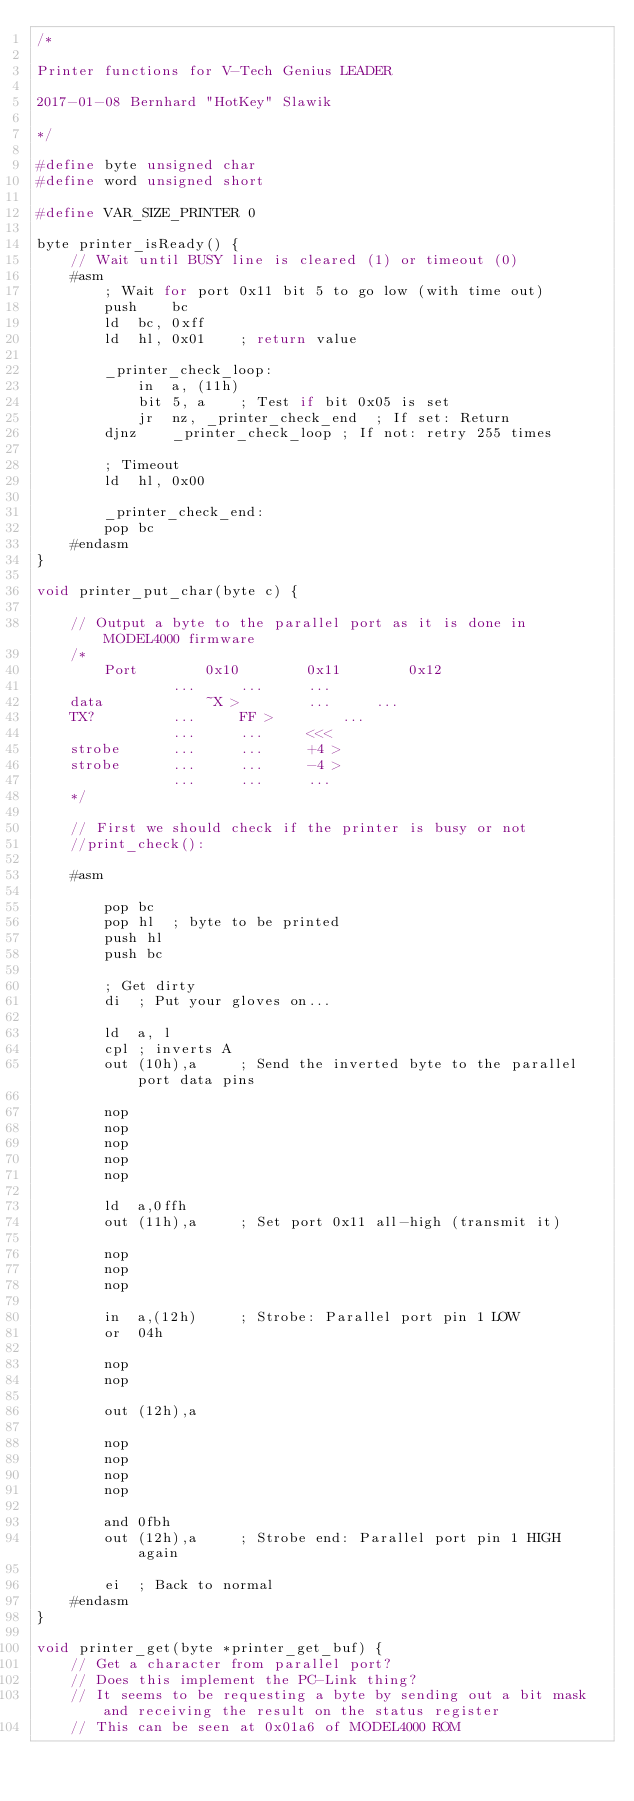<code> <loc_0><loc_0><loc_500><loc_500><_C_>/*

Printer functions for V-Tech Genius LEADER

2017-01-08 Bernhard "HotKey" Slawik

*/

#define byte unsigned char
#define word unsigned short

#define VAR_SIZE_PRINTER 0

byte printer_isReady() {
	// Wait until BUSY line is cleared (1) or timeout (0)
	#asm
		; Wait for port 0x11 bit 5 to go low (with time out)
		push	bc
		ld	bc, 0xff
		ld	hl, 0x01	; return value
		
		_printer_check_loop:
			in	a, (11h)
			bit	5, a	; Test if bit 0x05 is set
			jr	nz, _printer_check_end	; If set: Return
		djnz	_printer_check_loop	; If not: retry 255 times
		
		; Timeout
		ld	hl, 0x00
		
		_printer_check_end:
		pop	bc
	#endasm
}

void printer_put_char(byte c) {
	
	// Output a byte to the parallel port as it is done in MODEL4000 firmware
	/*
		Port		0x10		0x11		0x12
				...		...		...
	data			~X >		...		...
	TX?			...		FF >		...
				...		...		<<<
	strobe		...		...		+4 >
	strobe		...		...		-4 >
				...		...		...
	*/
	
	// First we should check if the printer is busy or not
	//print_check():
	
	#asm
		
		pop bc
		pop hl	; byte to be printed
		push hl
		push bc
		
		; Get dirty
		di	; Put your gloves on...
		
		ld	a, l
		cpl	; inverts A
		out	(10h),a		; Send the inverted byte to the parallel port data pins
	
		nop
		nop
		nop
		nop
		nop
		
		ld	a,0ffh
		out	(11h),a		; Set port 0x11 all-high (transmit it)
		
		nop
		nop
		nop
		
		in	a,(12h)		; Strobe: Parallel port pin 1 LOW
		or	04h
		
		nop
		nop
		
		out	(12h),a
		
		nop
		nop
		nop
		nop
		
		and	0fbh
		out	(12h),a		; Strobe end: Parallel port pin 1 HIGH again
		
		ei	; Back to normal
	#endasm
}

void printer_get(byte *printer_get_buf) {
	// Get a character from parallel port?
	// Does this implement the PC-Link thing?
	// It seems to be requesting a byte by sending out a bit mask and receiving the result on the status register
	// This can be seen at 0x01a6 of MODEL4000 ROM</code> 